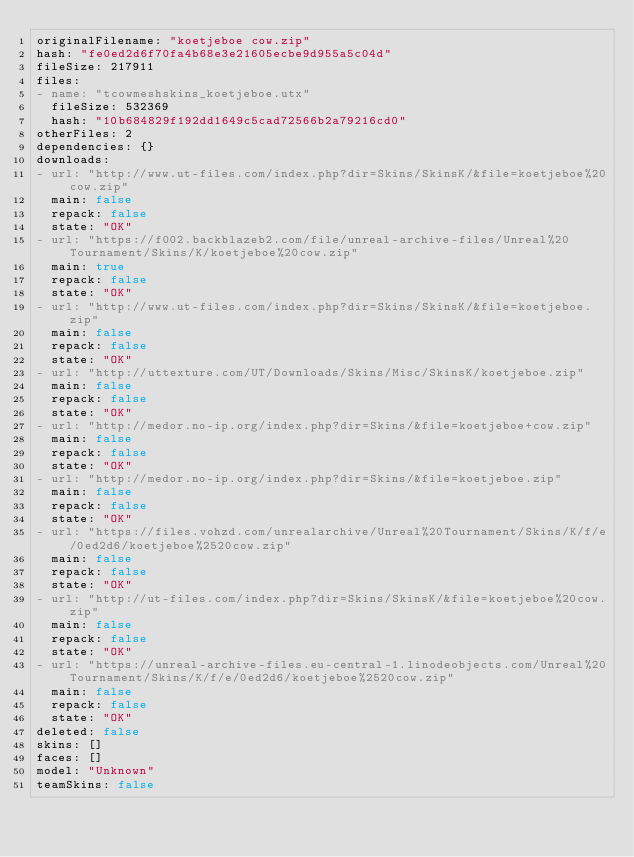Convert code to text. <code><loc_0><loc_0><loc_500><loc_500><_YAML_>originalFilename: "koetjeboe cow.zip"
hash: "fe0ed2d6f70fa4b68e3e21605ecbe9d955a5c04d"
fileSize: 217911
files:
- name: "tcowmeshskins_koetjeboe.utx"
  fileSize: 532369
  hash: "10b684829f192dd1649c5cad72566b2a79216cd0"
otherFiles: 2
dependencies: {}
downloads:
- url: "http://www.ut-files.com/index.php?dir=Skins/SkinsK/&file=koetjeboe%20cow.zip"
  main: false
  repack: false
  state: "OK"
- url: "https://f002.backblazeb2.com/file/unreal-archive-files/Unreal%20Tournament/Skins/K/koetjeboe%20cow.zip"
  main: true
  repack: false
  state: "OK"
- url: "http://www.ut-files.com/index.php?dir=Skins/SkinsK/&file=koetjeboe.zip"
  main: false
  repack: false
  state: "OK"
- url: "http://uttexture.com/UT/Downloads/Skins/Misc/SkinsK/koetjeboe.zip"
  main: false
  repack: false
  state: "OK"
- url: "http://medor.no-ip.org/index.php?dir=Skins/&file=koetjeboe+cow.zip"
  main: false
  repack: false
  state: "OK"
- url: "http://medor.no-ip.org/index.php?dir=Skins/&file=koetjeboe.zip"
  main: false
  repack: false
  state: "OK"
- url: "https://files.vohzd.com/unrealarchive/Unreal%20Tournament/Skins/K/f/e/0ed2d6/koetjeboe%2520cow.zip"
  main: false
  repack: false
  state: "OK"
- url: "http://ut-files.com/index.php?dir=Skins/SkinsK/&file=koetjeboe%20cow.zip"
  main: false
  repack: false
  state: "OK"
- url: "https://unreal-archive-files.eu-central-1.linodeobjects.com/Unreal%20Tournament/Skins/K/f/e/0ed2d6/koetjeboe%2520cow.zip"
  main: false
  repack: false
  state: "OK"
deleted: false
skins: []
faces: []
model: "Unknown"
teamSkins: false
</code> 